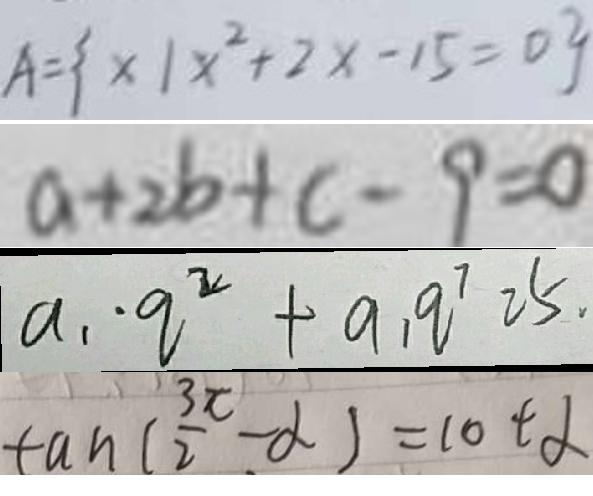<formula> <loc_0><loc_0><loc_500><loc_500>A = \{ x \vert x ^ { 2 } + 2 x - 1 5 = 0 \} 
 a + 2 b + c - 9 = 0 
 a _ { 1 } \cdot q ^ { 2 } + a _ { 1 } q ^ { 7 } 2 5 . 
 \tan ( \frac { 3 \pi } { 2 } - \alpha ) = \cot \alpha</formula> 